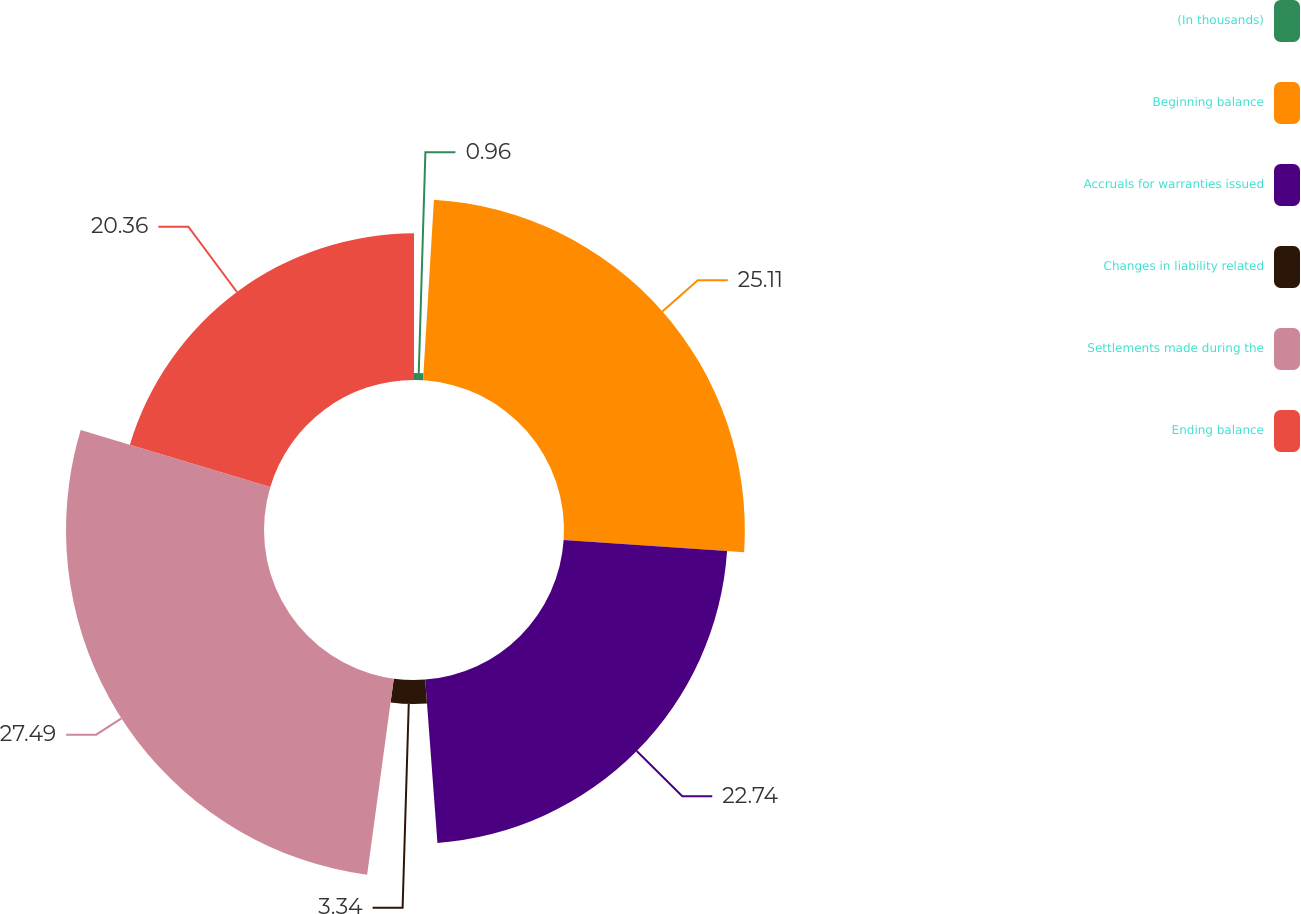Convert chart to OTSL. <chart><loc_0><loc_0><loc_500><loc_500><pie_chart><fcel>(In thousands)<fcel>Beginning balance<fcel>Accruals for warranties issued<fcel>Changes in liability related<fcel>Settlements made during the<fcel>Ending balance<nl><fcel>0.96%<fcel>25.11%<fcel>22.74%<fcel>3.34%<fcel>27.49%<fcel>20.36%<nl></chart> 